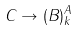Convert formula to latex. <formula><loc_0><loc_0><loc_500><loc_500>C \rightarrow ( B ) _ { k } ^ { A }</formula> 